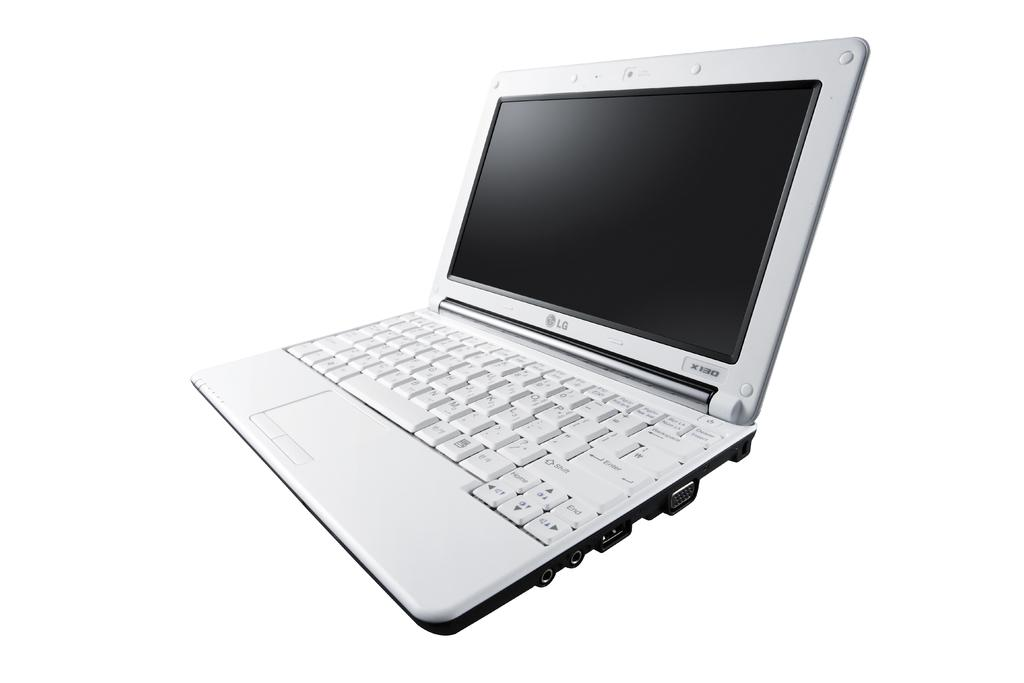What electronic device is visible in the image? There is a laptop in the image. Can you tell me how many times the laptop swings back and forth in the image? There is no swing present in the image, as it features a laptop. What is the laptop's opinion on the current political climate? The laptop does not have an opinion, as it is an inanimate object. 